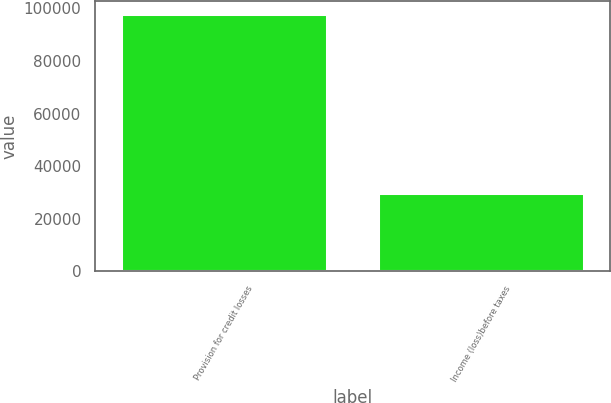Convert chart to OTSL. <chart><loc_0><loc_0><loc_500><loc_500><bar_chart><fcel>Provision for credit losses<fcel>Income (loss)before taxes<nl><fcel>97816<fcel>29673<nl></chart> 